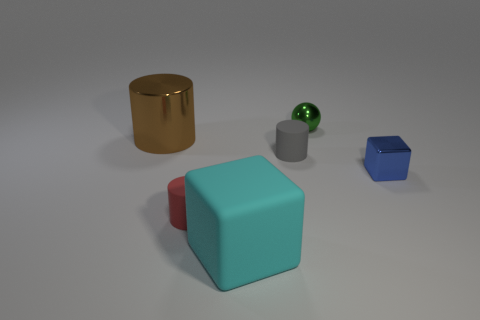What is the gray cylinder made of? While the gray cylinder in the image appears to have a matte surface typical of materials like plastic or metal, without additional context or information, it's challenging to determine the exact material. However, if we were to make an educated guess based on the visual cues, the cylinder could be made of a brushed metal or a sturdy type of plastic. 